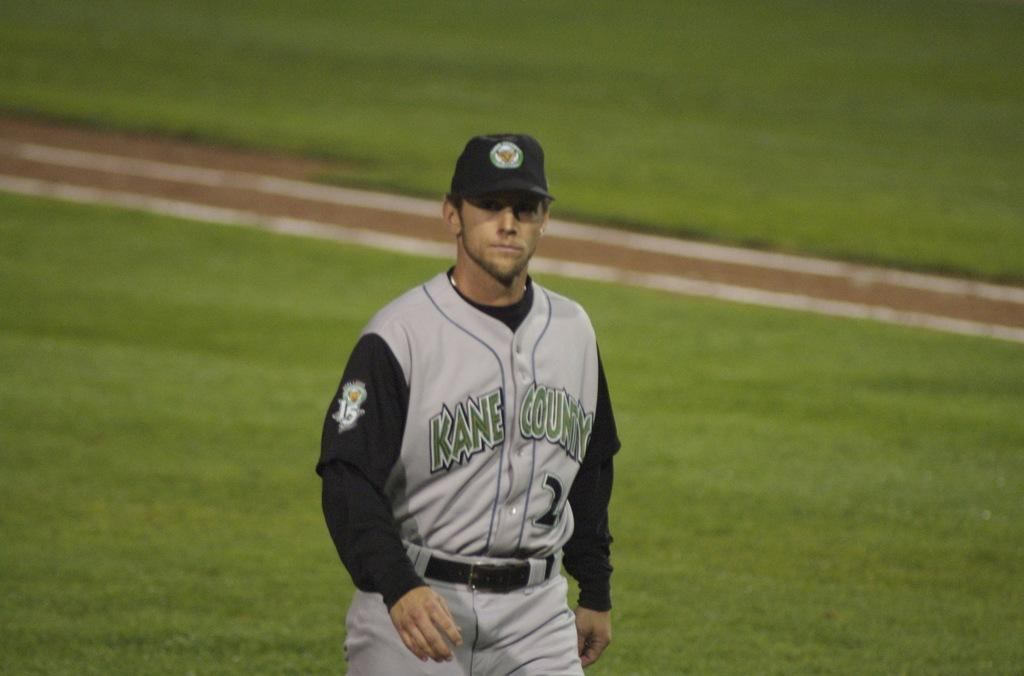<image>
Offer a succinct explanation of the picture presented. A Kane County baseball player wearing black and grey looks at the camera as he walks on the playing field. 